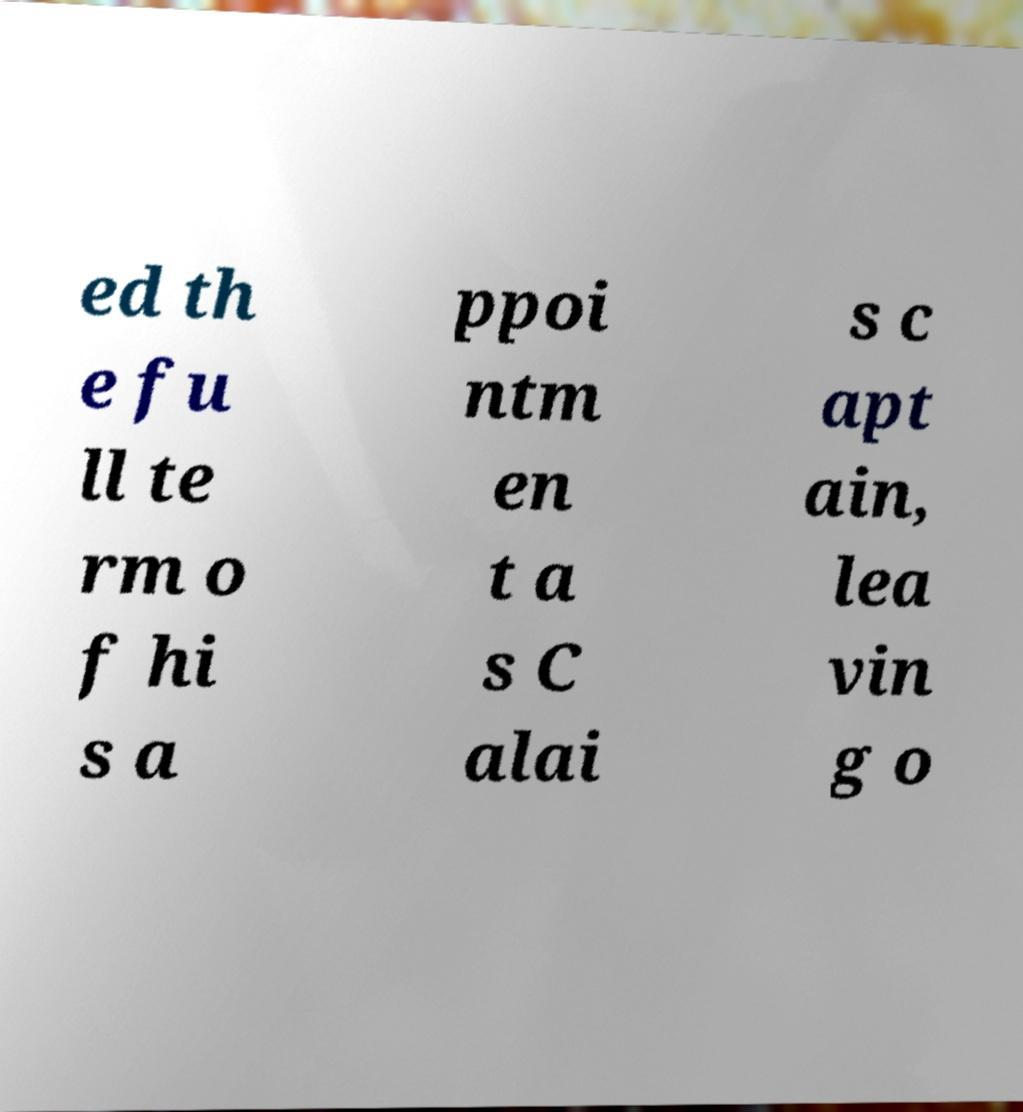What messages or text are displayed in this image? I need them in a readable, typed format. ed th e fu ll te rm o f hi s a ppoi ntm en t a s C alai s c apt ain, lea vin g o 